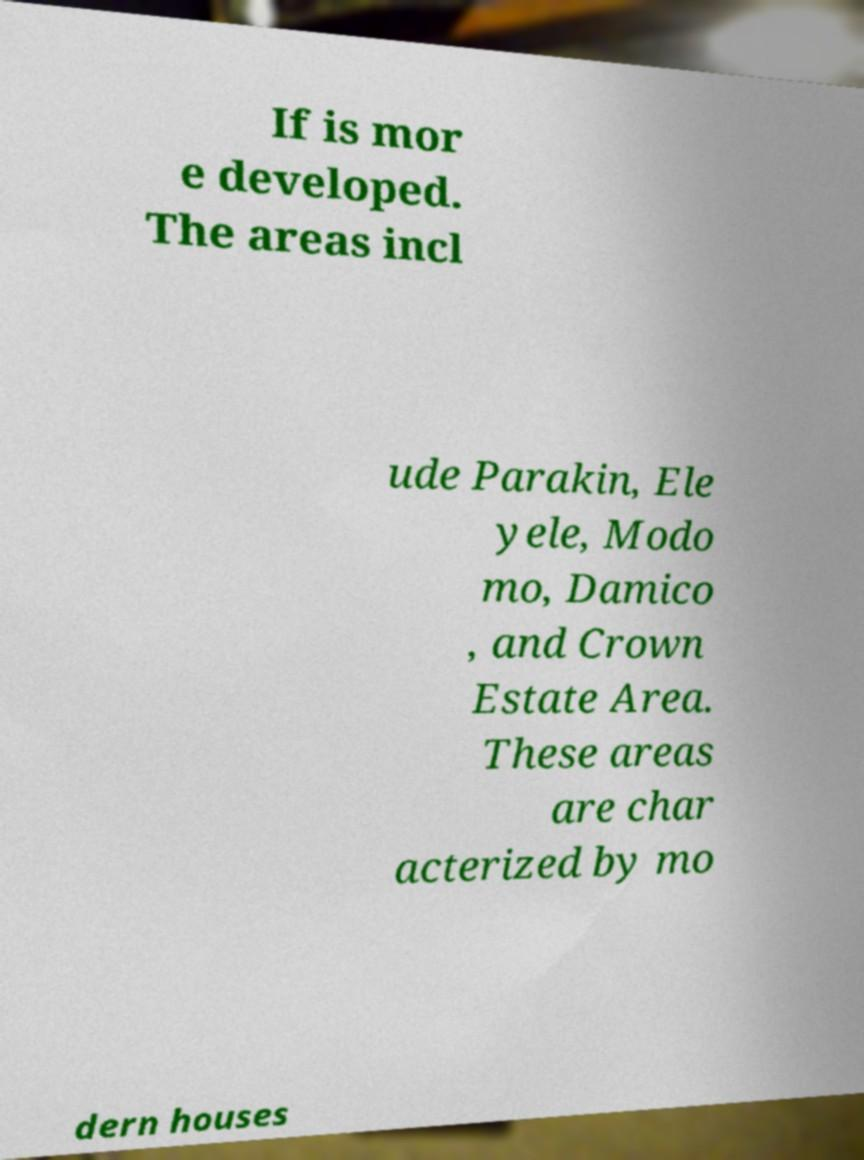Can you read and provide the text displayed in the image?This photo seems to have some interesting text. Can you extract and type it out for me? If is mor e developed. The areas incl ude Parakin, Ele yele, Modo mo, Damico , and Crown Estate Area. These areas are char acterized by mo dern houses 